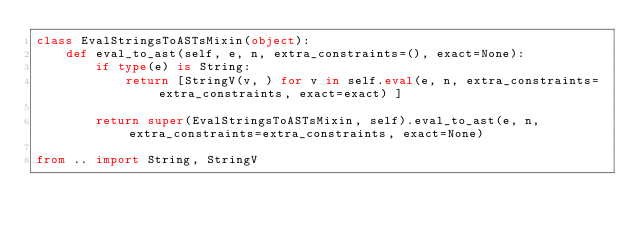<code> <loc_0><loc_0><loc_500><loc_500><_Python_>class EvalStringsToASTsMixin(object):
    def eval_to_ast(self, e, n, extra_constraints=(), exact=None):
        if type(e) is String:
            return [StringV(v, ) for v in self.eval(e, n, extra_constraints=extra_constraints, exact=exact) ]

        return super(EvalStringsToASTsMixin, self).eval_to_ast(e, n, extra_constraints=extra_constraints, exact=None)

from .. import String, StringV
</code> 